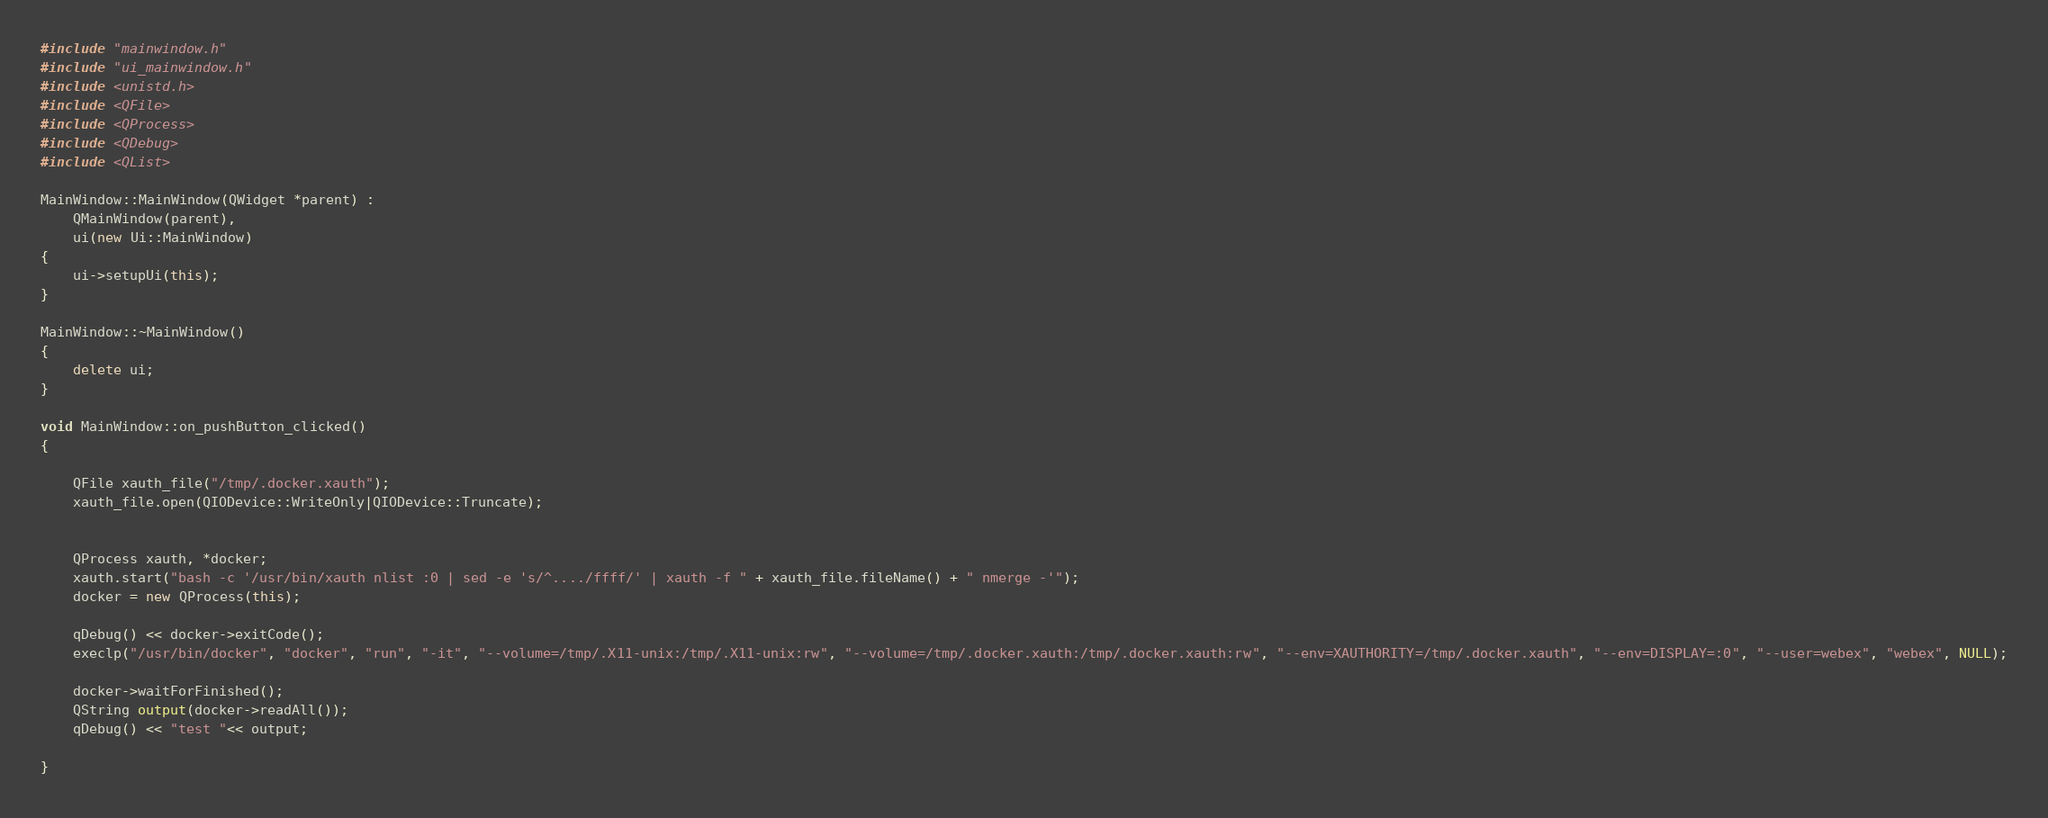<code> <loc_0><loc_0><loc_500><loc_500><_C++_>#include "mainwindow.h"
#include "ui_mainwindow.h"
#include <unistd.h>
#include <QFile>
#include <QProcess>
#include <QDebug>
#include <QList>

MainWindow::MainWindow(QWidget *parent) :
    QMainWindow(parent),
    ui(new Ui::MainWindow)
{
    ui->setupUi(this);
}

MainWindow::~MainWindow()
{
    delete ui;
}

void MainWindow::on_pushButton_clicked()
{

    QFile xauth_file("/tmp/.docker.xauth");
    xauth_file.open(QIODevice::WriteOnly|QIODevice::Truncate);


    QProcess xauth, *docker;
    xauth.start("bash -c '/usr/bin/xauth nlist :0 | sed -e 's/^..../ffff/' | xauth -f " + xauth_file.fileName() + " nmerge -'");
    docker = new QProcess(this);

    qDebug() << docker->exitCode();
    execlp("/usr/bin/docker", "docker", "run", "-it", "--volume=/tmp/.X11-unix:/tmp/.X11-unix:rw", "--volume=/tmp/.docker.xauth:/tmp/.docker.xauth:rw", "--env=XAUTHORITY=/tmp/.docker.xauth", "--env=DISPLAY=:0", "--user=webex", "webex", NULL);

    docker->waitForFinished();
    QString output(docker->readAll());
    qDebug() << "test "<< output;

}
</code> 